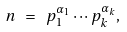<formula> <loc_0><loc_0><loc_500><loc_500>n \ = \ p _ { 1 } ^ { \alpha _ { 1 } } \cdots p _ { k } ^ { \alpha _ { k } } ,</formula> 